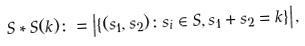<formula> <loc_0><loc_0><loc_500><loc_500>S \ast S ( k ) \colon = \left | \{ ( s _ { 1 } , s _ { 2 } ) \colon s _ { i } \in S , s _ { 1 } + s _ { 2 } = k \} \right | ,</formula> 